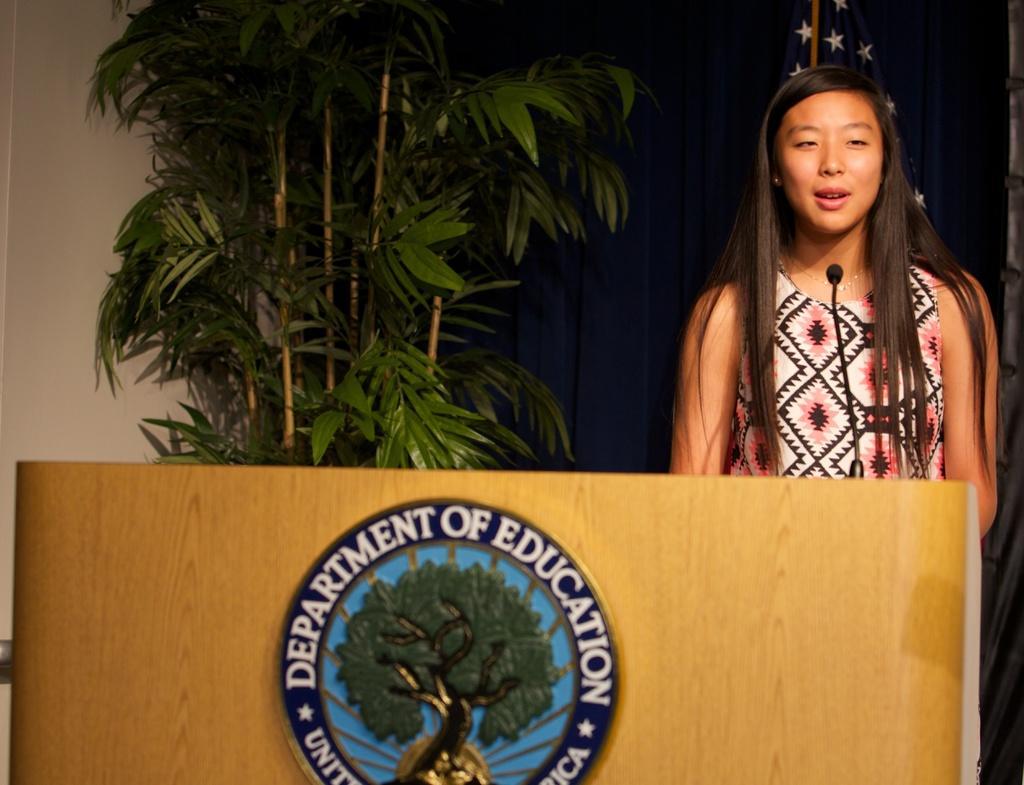Please provide a concise description of this image. In the picture there is a woman standing near the podium, on the podium there is a microphone present to the stand, there is a symbol present with some text, behind the woman there is a houseplant, there is a curtain, there may be a flag. 